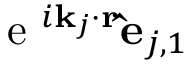<formula> <loc_0><loc_0><loc_500><loc_500>e ^ { i k _ { j } \cdot r } \hat { e } _ { j , 1 }</formula> 